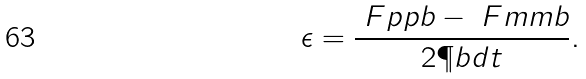Convert formula to latex. <formula><loc_0><loc_0><loc_500><loc_500>\epsilon = \frac { \ F p p b - \ F m m b } { 2 \P b d t } .</formula> 